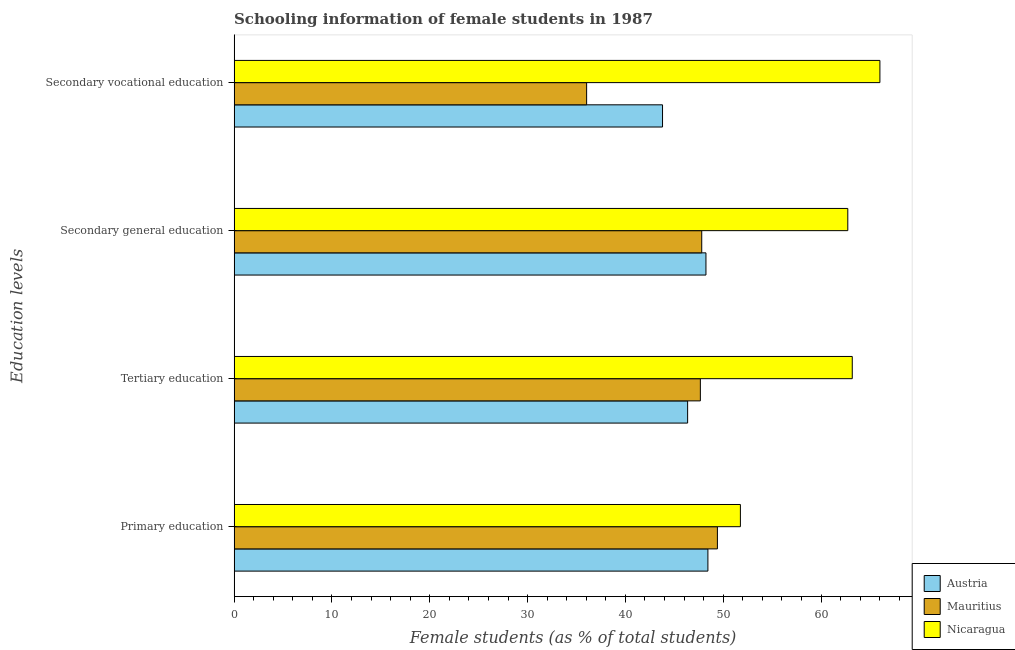How many different coloured bars are there?
Keep it short and to the point. 3. How many bars are there on the 4th tick from the bottom?
Keep it short and to the point. 3. What is the label of the 2nd group of bars from the top?
Provide a succinct answer. Secondary general education. What is the percentage of female students in tertiary education in Mauritius?
Provide a short and direct response. 47.66. Across all countries, what is the maximum percentage of female students in secondary education?
Your answer should be compact. 62.74. Across all countries, what is the minimum percentage of female students in secondary vocational education?
Give a very brief answer. 36.04. In which country was the percentage of female students in secondary vocational education maximum?
Keep it short and to the point. Nicaragua. What is the total percentage of female students in primary education in the graph?
Provide a short and direct response. 149.6. What is the difference between the percentage of female students in primary education in Austria and that in Mauritius?
Offer a terse response. -0.97. What is the difference between the percentage of female students in secondary education in Austria and the percentage of female students in tertiary education in Nicaragua?
Your answer should be compact. -14.96. What is the average percentage of female students in primary education per country?
Provide a succinct answer. 49.87. What is the difference between the percentage of female students in tertiary education and percentage of female students in secondary vocational education in Austria?
Give a very brief answer. 2.57. In how many countries, is the percentage of female students in tertiary education greater than 24 %?
Make the answer very short. 3. What is the ratio of the percentage of female students in primary education in Nicaragua to that in Austria?
Keep it short and to the point. 1.07. Is the percentage of female students in secondary vocational education in Nicaragua less than that in Austria?
Ensure brevity in your answer.  No. Is the difference between the percentage of female students in tertiary education in Austria and Mauritius greater than the difference between the percentage of female students in secondary vocational education in Austria and Mauritius?
Ensure brevity in your answer.  No. What is the difference between the highest and the second highest percentage of female students in secondary education?
Your response must be concise. 14.5. What is the difference between the highest and the lowest percentage of female students in secondary education?
Provide a succinct answer. 14.93. In how many countries, is the percentage of female students in primary education greater than the average percentage of female students in primary education taken over all countries?
Provide a short and direct response. 1. Is it the case that in every country, the sum of the percentage of female students in tertiary education and percentage of female students in secondary education is greater than the sum of percentage of female students in secondary vocational education and percentage of female students in primary education?
Your answer should be very brief. Yes. What does the 1st bar from the top in Secondary vocational education represents?
Make the answer very short. Nicaragua. What does the 3rd bar from the bottom in Secondary vocational education represents?
Provide a succinct answer. Nicaragua. Is it the case that in every country, the sum of the percentage of female students in primary education and percentage of female students in tertiary education is greater than the percentage of female students in secondary education?
Your answer should be very brief. Yes. How many countries are there in the graph?
Offer a very short reply. 3. Where does the legend appear in the graph?
Give a very brief answer. Bottom right. How are the legend labels stacked?
Make the answer very short. Vertical. What is the title of the graph?
Provide a short and direct response. Schooling information of female students in 1987. Does "Armenia" appear as one of the legend labels in the graph?
Your answer should be very brief. No. What is the label or title of the X-axis?
Your answer should be very brief. Female students (as % of total students). What is the label or title of the Y-axis?
Your answer should be compact. Education levels. What is the Female students (as % of total students) in Austria in Primary education?
Your answer should be compact. 48.44. What is the Female students (as % of total students) in Mauritius in Primary education?
Give a very brief answer. 49.41. What is the Female students (as % of total students) of Nicaragua in Primary education?
Offer a terse response. 51.76. What is the Female students (as % of total students) in Austria in Tertiary education?
Make the answer very short. 46.36. What is the Female students (as % of total students) in Mauritius in Tertiary education?
Offer a terse response. 47.66. What is the Female students (as % of total students) of Nicaragua in Tertiary education?
Give a very brief answer. 63.19. What is the Female students (as % of total students) in Austria in Secondary general education?
Provide a succinct answer. 48.24. What is the Female students (as % of total students) of Mauritius in Secondary general education?
Provide a succinct answer. 47.81. What is the Female students (as % of total students) in Nicaragua in Secondary general education?
Your answer should be very brief. 62.74. What is the Female students (as % of total students) of Austria in Secondary vocational education?
Your response must be concise. 43.8. What is the Female students (as % of total students) of Mauritius in Secondary vocational education?
Your answer should be compact. 36.04. What is the Female students (as % of total students) in Nicaragua in Secondary vocational education?
Make the answer very short. 66.02. Across all Education levels, what is the maximum Female students (as % of total students) in Austria?
Your answer should be compact. 48.44. Across all Education levels, what is the maximum Female students (as % of total students) of Mauritius?
Offer a terse response. 49.41. Across all Education levels, what is the maximum Female students (as % of total students) in Nicaragua?
Offer a very short reply. 66.02. Across all Education levels, what is the minimum Female students (as % of total students) of Austria?
Provide a short and direct response. 43.8. Across all Education levels, what is the minimum Female students (as % of total students) of Mauritius?
Offer a terse response. 36.04. Across all Education levels, what is the minimum Female students (as % of total students) in Nicaragua?
Give a very brief answer. 51.76. What is the total Female students (as % of total students) in Austria in the graph?
Offer a very short reply. 186.83. What is the total Female students (as % of total students) in Mauritius in the graph?
Offer a very short reply. 180.91. What is the total Female students (as % of total students) of Nicaragua in the graph?
Ensure brevity in your answer.  243.71. What is the difference between the Female students (as % of total students) in Austria in Primary education and that in Tertiary education?
Your answer should be compact. 2.07. What is the difference between the Female students (as % of total students) of Mauritius in Primary education and that in Tertiary education?
Offer a terse response. 1.74. What is the difference between the Female students (as % of total students) in Nicaragua in Primary education and that in Tertiary education?
Your answer should be compact. -11.44. What is the difference between the Female students (as % of total students) of Austria in Primary education and that in Secondary general education?
Provide a short and direct response. 0.2. What is the difference between the Female students (as % of total students) of Mauritius in Primary education and that in Secondary general education?
Provide a short and direct response. 1.6. What is the difference between the Female students (as % of total students) in Nicaragua in Primary education and that in Secondary general education?
Your response must be concise. -10.98. What is the difference between the Female students (as % of total students) of Austria in Primary education and that in Secondary vocational education?
Offer a very short reply. 4.64. What is the difference between the Female students (as % of total students) in Mauritius in Primary education and that in Secondary vocational education?
Ensure brevity in your answer.  13.37. What is the difference between the Female students (as % of total students) in Nicaragua in Primary education and that in Secondary vocational education?
Make the answer very short. -14.26. What is the difference between the Female students (as % of total students) in Austria in Tertiary education and that in Secondary general education?
Give a very brief answer. -1.87. What is the difference between the Female students (as % of total students) in Mauritius in Tertiary education and that in Secondary general education?
Make the answer very short. -0.14. What is the difference between the Female students (as % of total students) of Nicaragua in Tertiary education and that in Secondary general education?
Ensure brevity in your answer.  0.46. What is the difference between the Female students (as % of total students) of Austria in Tertiary education and that in Secondary vocational education?
Offer a terse response. 2.57. What is the difference between the Female students (as % of total students) in Mauritius in Tertiary education and that in Secondary vocational education?
Your response must be concise. 11.63. What is the difference between the Female students (as % of total students) of Nicaragua in Tertiary education and that in Secondary vocational education?
Offer a very short reply. -2.83. What is the difference between the Female students (as % of total students) in Austria in Secondary general education and that in Secondary vocational education?
Make the answer very short. 4.44. What is the difference between the Female students (as % of total students) of Mauritius in Secondary general education and that in Secondary vocational education?
Provide a short and direct response. 11.77. What is the difference between the Female students (as % of total students) in Nicaragua in Secondary general education and that in Secondary vocational education?
Offer a terse response. -3.28. What is the difference between the Female students (as % of total students) of Austria in Primary education and the Female students (as % of total students) of Mauritius in Tertiary education?
Your response must be concise. 0.77. What is the difference between the Female students (as % of total students) of Austria in Primary education and the Female students (as % of total students) of Nicaragua in Tertiary education?
Keep it short and to the point. -14.76. What is the difference between the Female students (as % of total students) of Mauritius in Primary education and the Female students (as % of total students) of Nicaragua in Tertiary education?
Your response must be concise. -13.79. What is the difference between the Female students (as % of total students) of Austria in Primary education and the Female students (as % of total students) of Mauritius in Secondary general education?
Provide a succinct answer. 0.63. What is the difference between the Female students (as % of total students) of Austria in Primary education and the Female students (as % of total students) of Nicaragua in Secondary general education?
Provide a short and direct response. -14.3. What is the difference between the Female students (as % of total students) in Mauritius in Primary education and the Female students (as % of total students) in Nicaragua in Secondary general education?
Keep it short and to the point. -13.33. What is the difference between the Female students (as % of total students) of Austria in Primary education and the Female students (as % of total students) of Mauritius in Secondary vocational education?
Provide a short and direct response. 12.4. What is the difference between the Female students (as % of total students) in Austria in Primary education and the Female students (as % of total students) in Nicaragua in Secondary vocational education?
Your answer should be compact. -17.58. What is the difference between the Female students (as % of total students) in Mauritius in Primary education and the Female students (as % of total students) in Nicaragua in Secondary vocational education?
Give a very brief answer. -16.61. What is the difference between the Female students (as % of total students) of Austria in Tertiary education and the Female students (as % of total students) of Mauritius in Secondary general education?
Your answer should be compact. -1.44. What is the difference between the Female students (as % of total students) in Austria in Tertiary education and the Female students (as % of total students) in Nicaragua in Secondary general education?
Provide a succinct answer. -16.37. What is the difference between the Female students (as % of total students) of Mauritius in Tertiary education and the Female students (as % of total students) of Nicaragua in Secondary general education?
Keep it short and to the point. -15.07. What is the difference between the Female students (as % of total students) of Austria in Tertiary education and the Female students (as % of total students) of Mauritius in Secondary vocational education?
Offer a very short reply. 10.33. What is the difference between the Female students (as % of total students) in Austria in Tertiary education and the Female students (as % of total students) in Nicaragua in Secondary vocational education?
Your answer should be compact. -19.66. What is the difference between the Female students (as % of total students) of Mauritius in Tertiary education and the Female students (as % of total students) of Nicaragua in Secondary vocational education?
Provide a short and direct response. -18.36. What is the difference between the Female students (as % of total students) of Austria in Secondary general education and the Female students (as % of total students) of Mauritius in Secondary vocational education?
Provide a short and direct response. 12.2. What is the difference between the Female students (as % of total students) of Austria in Secondary general education and the Female students (as % of total students) of Nicaragua in Secondary vocational education?
Make the answer very short. -17.78. What is the difference between the Female students (as % of total students) of Mauritius in Secondary general education and the Female students (as % of total students) of Nicaragua in Secondary vocational education?
Offer a terse response. -18.22. What is the average Female students (as % of total students) in Austria per Education levels?
Keep it short and to the point. 46.71. What is the average Female students (as % of total students) of Mauritius per Education levels?
Keep it short and to the point. 45.23. What is the average Female students (as % of total students) of Nicaragua per Education levels?
Provide a short and direct response. 60.93. What is the difference between the Female students (as % of total students) in Austria and Female students (as % of total students) in Mauritius in Primary education?
Provide a succinct answer. -0.97. What is the difference between the Female students (as % of total students) in Austria and Female students (as % of total students) in Nicaragua in Primary education?
Your answer should be very brief. -3.32. What is the difference between the Female students (as % of total students) in Mauritius and Female students (as % of total students) in Nicaragua in Primary education?
Offer a very short reply. -2.35. What is the difference between the Female students (as % of total students) in Austria and Female students (as % of total students) in Mauritius in Tertiary education?
Your answer should be very brief. -1.3. What is the difference between the Female students (as % of total students) of Austria and Female students (as % of total students) of Nicaragua in Tertiary education?
Ensure brevity in your answer.  -16.83. What is the difference between the Female students (as % of total students) in Mauritius and Female students (as % of total students) in Nicaragua in Tertiary education?
Provide a succinct answer. -15.53. What is the difference between the Female students (as % of total students) in Austria and Female students (as % of total students) in Mauritius in Secondary general education?
Ensure brevity in your answer.  0.43. What is the difference between the Female students (as % of total students) of Austria and Female students (as % of total students) of Nicaragua in Secondary general education?
Your answer should be compact. -14.5. What is the difference between the Female students (as % of total students) in Mauritius and Female students (as % of total students) in Nicaragua in Secondary general education?
Your answer should be compact. -14.93. What is the difference between the Female students (as % of total students) in Austria and Female students (as % of total students) in Mauritius in Secondary vocational education?
Your answer should be very brief. 7.76. What is the difference between the Female students (as % of total students) in Austria and Female students (as % of total students) in Nicaragua in Secondary vocational education?
Keep it short and to the point. -22.22. What is the difference between the Female students (as % of total students) in Mauritius and Female students (as % of total students) in Nicaragua in Secondary vocational education?
Give a very brief answer. -29.98. What is the ratio of the Female students (as % of total students) of Austria in Primary education to that in Tertiary education?
Your response must be concise. 1.04. What is the ratio of the Female students (as % of total students) in Mauritius in Primary education to that in Tertiary education?
Make the answer very short. 1.04. What is the ratio of the Female students (as % of total students) of Nicaragua in Primary education to that in Tertiary education?
Your response must be concise. 0.82. What is the ratio of the Female students (as % of total students) of Mauritius in Primary education to that in Secondary general education?
Offer a terse response. 1.03. What is the ratio of the Female students (as % of total students) in Nicaragua in Primary education to that in Secondary general education?
Keep it short and to the point. 0.82. What is the ratio of the Female students (as % of total students) in Austria in Primary education to that in Secondary vocational education?
Your answer should be compact. 1.11. What is the ratio of the Female students (as % of total students) of Mauritius in Primary education to that in Secondary vocational education?
Provide a succinct answer. 1.37. What is the ratio of the Female students (as % of total students) of Nicaragua in Primary education to that in Secondary vocational education?
Your answer should be very brief. 0.78. What is the ratio of the Female students (as % of total students) of Austria in Tertiary education to that in Secondary general education?
Offer a very short reply. 0.96. What is the ratio of the Female students (as % of total students) in Mauritius in Tertiary education to that in Secondary general education?
Offer a terse response. 1. What is the ratio of the Female students (as % of total students) of Nicaragua in Tertiary education to that in Secondary general education?
Your response must be concise. 1.01. What is the ratio of the Female students (as % of total students) of Austria in Tertiary education to that in Secondary vocational education?
Your response must be concise. 1.06. What is the ratio of the Female students (as % of total students) in Mauritius in Tertiary education to that in Secondary vocational education?
Provide a short and direct response. 1.32. What is the ratio of the Female students (as % of total students) of Nicaragua in Tertiary education to that in Secondary vocational education?
Offer a very short reply. 0.96. What is the ratio of the Female students (as % of total students) of Austria in Secondary general education to that in Secondary vocational education?
Offer a terse response. 1.1. What is the ratio of the Female students (as % of total students) in Mauritius in Secondary general education to that in Secondary vocational education?
Make the answer very short. 1.33. What is the ratio of the Female students (as % of total students) in Nicaragua in Secondary general education to that in Secondary vocational education?
Offer a very short reply. 0.95. What is the difference between the highest and the second highest Female students (as % of total students) in Austria?
Your answer should be very brief. 0.2. What is the difference between the highest and the second highest Female students (as % of total students) in Mauritius?
Give a very brief answer. 1.6. What is the difference between the highest and the second highest Female students (as % of total students) of Nicaragua?
Ensure brevity in your answer.  2.83. What is the difference between the highest and the lowest Female students (as % of total students) in Austria?
Your response must be concise. 4.64. What is the difference between the highest and the lowest Female students (as % of total students) of Mauritius?
Make the answer very short. 13.37. What is the difference between the highest and the lowest Female students (as % of total students) of Nicaragua?
Offer a terse response. 14.26. 